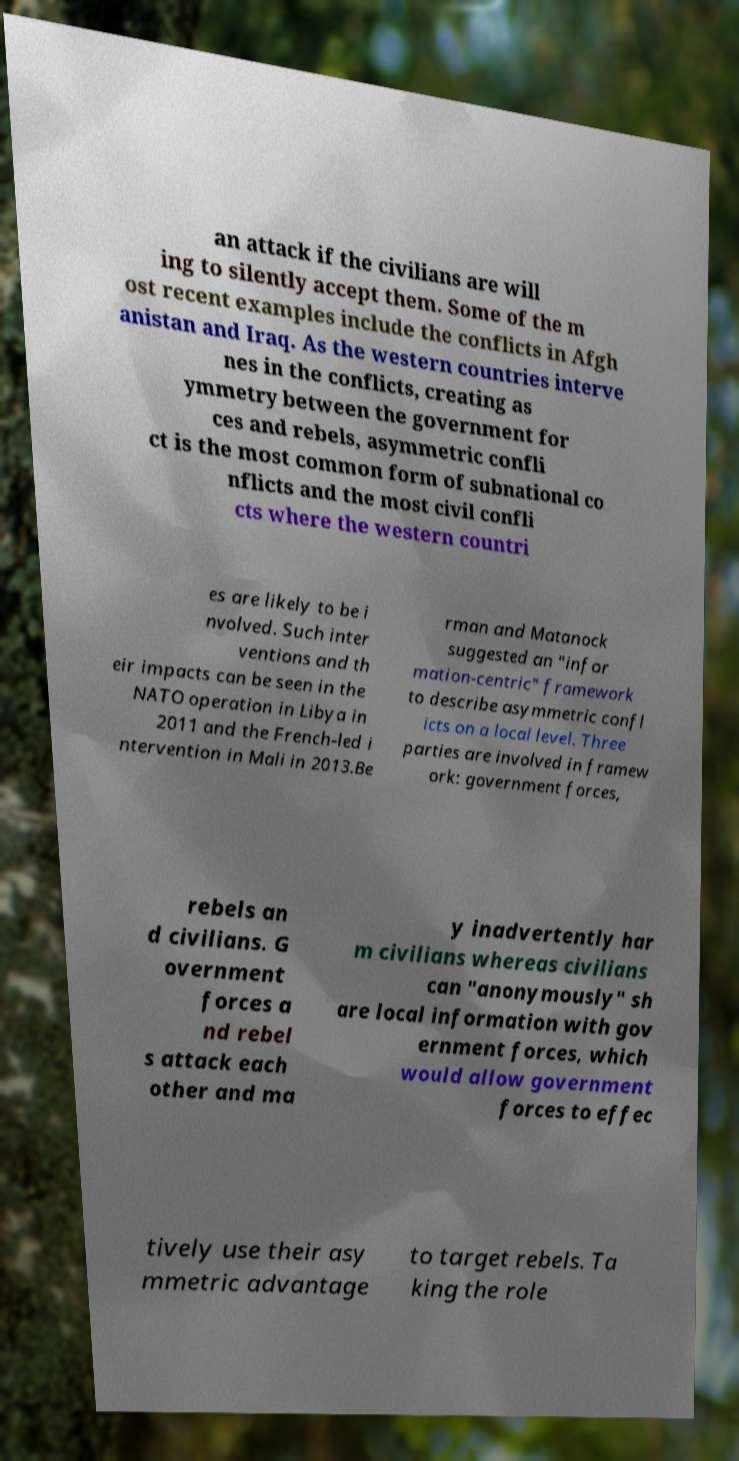Can you read and provide the text displayed in the image?This photo seems to have some interesting text. Can you extract and type it out for me? an attack if the civilians are will ing to silently accept them. Some of the m ost recent examples include the conflicts in Afgh anistan and Iraq. As the western countries interve nes in the conflicts, creating as ymmetry between the government for ces and rebels, asymmetric confli ct is the most common form of subnational co nflicts and the most civil confli cts where the western countri es are likely to be i nvolved. Such inter ventions and th eir impacts can be seen in the NATO operation in Libya in 2011 and the French-led i ntervention in Mali in 2013.Be rman and Matanock suggested an "infor mation-centric" framework to describe asymmetric confl icts on a local level. Three parties are involved in framew ork: government forces, rebels an d civilians. G overnment forces a nd rebel s attack each other and ma y inadvertently har m civilians whereas civilians can "anonymously" sh are local information with gov ernment forces, which would allow government forces to effec tively use their asy mmetric advantage to target rebels. Ta king the role 